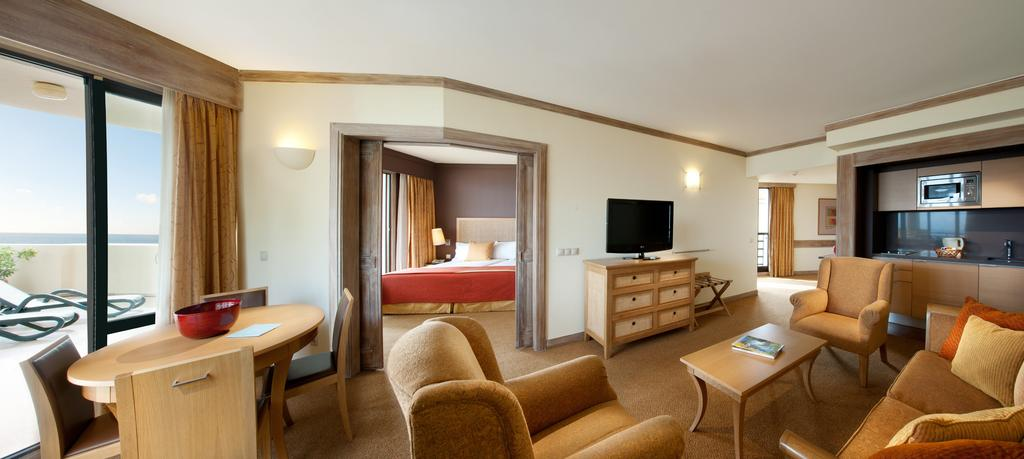What type of electronic device is visible in the image? There is a television in the image. What type of furniture is present for seating? There is a couch and chairs in the image. What type of accessory can be seen on the furniture? There are pillows in the image. What type of kitchen appliance is visible in the image? There is a microwave oven in the image. What type of furniture is present for sleeping? There is a bed in the image. What type of furniture is present for eating or working? There is a table in the image. How many slaves are visible in the image? There are no slaves present in the image. What type of blade is being used in the image? There is no blade present in the image. 